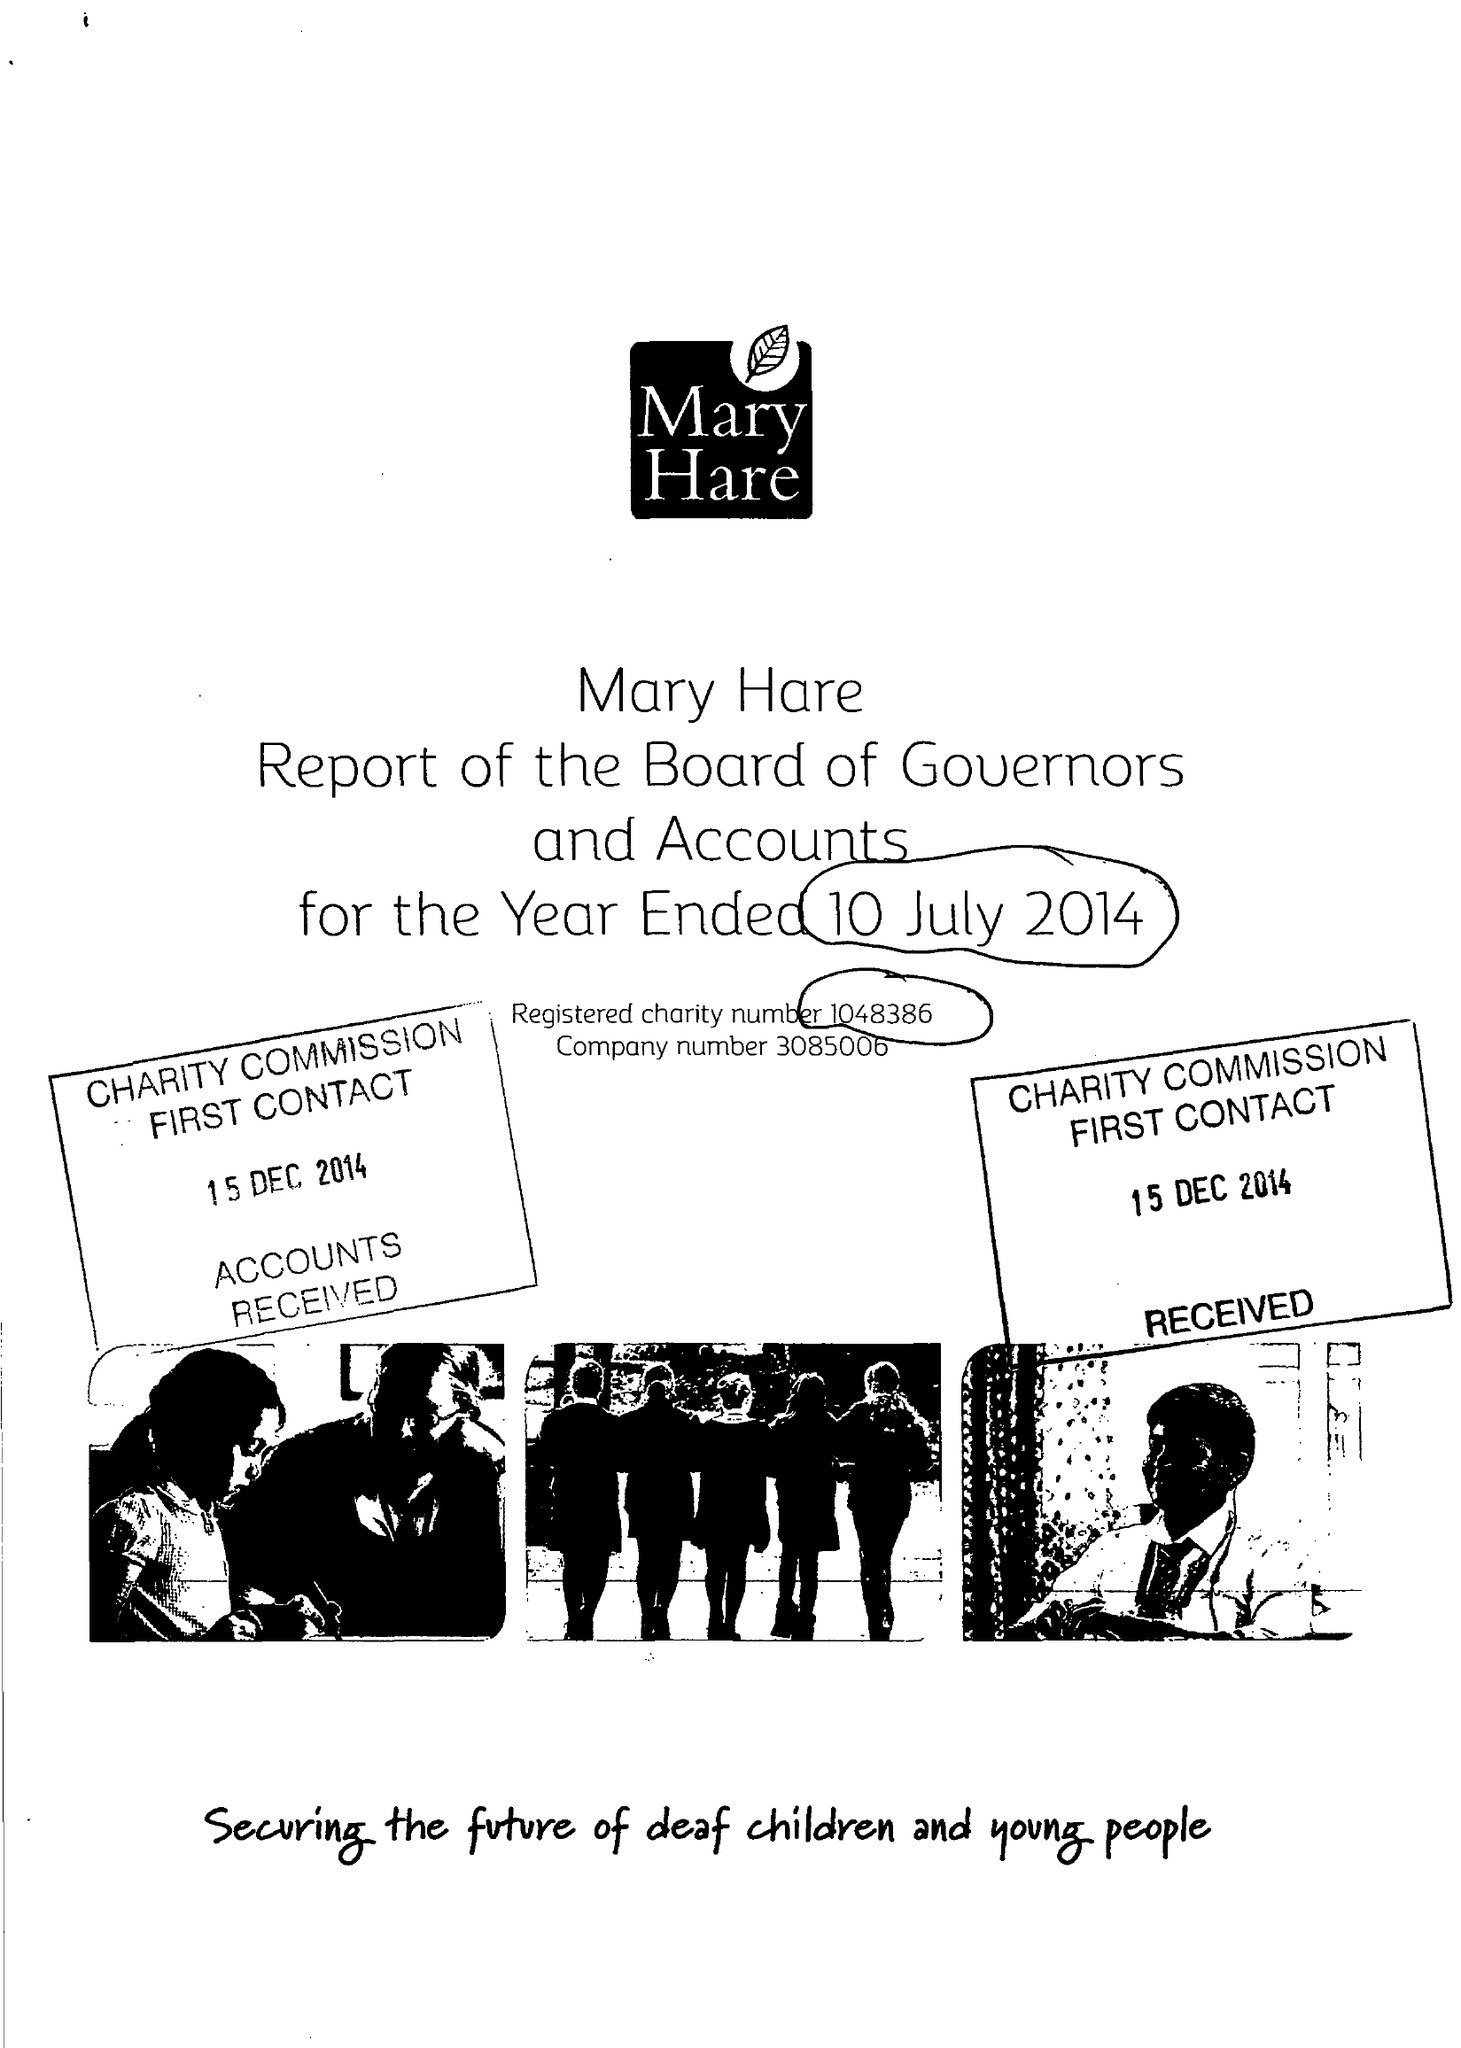What is the value for the income_annually_in_british_pounds?
Answer the question using a single word or phrase. 10377000.00 